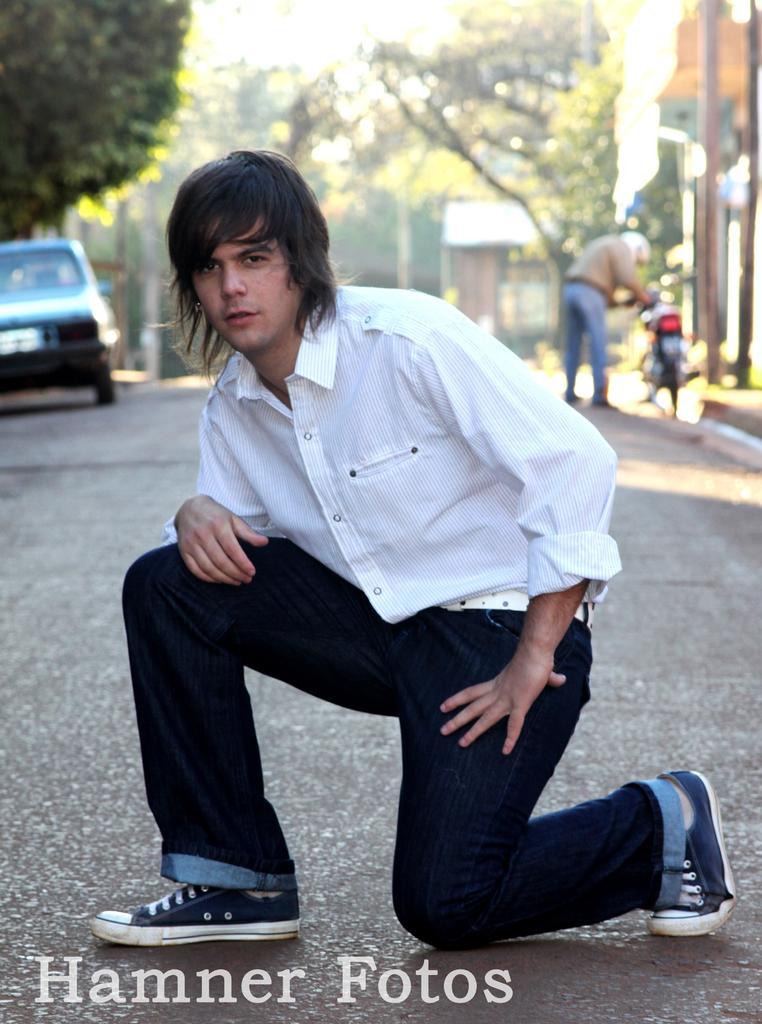Please provide a concise description of this image. As we can see in the image in the front there is a man wearing white color shirt. In the background there is a motorcycle, a person, car, houses and trees. 